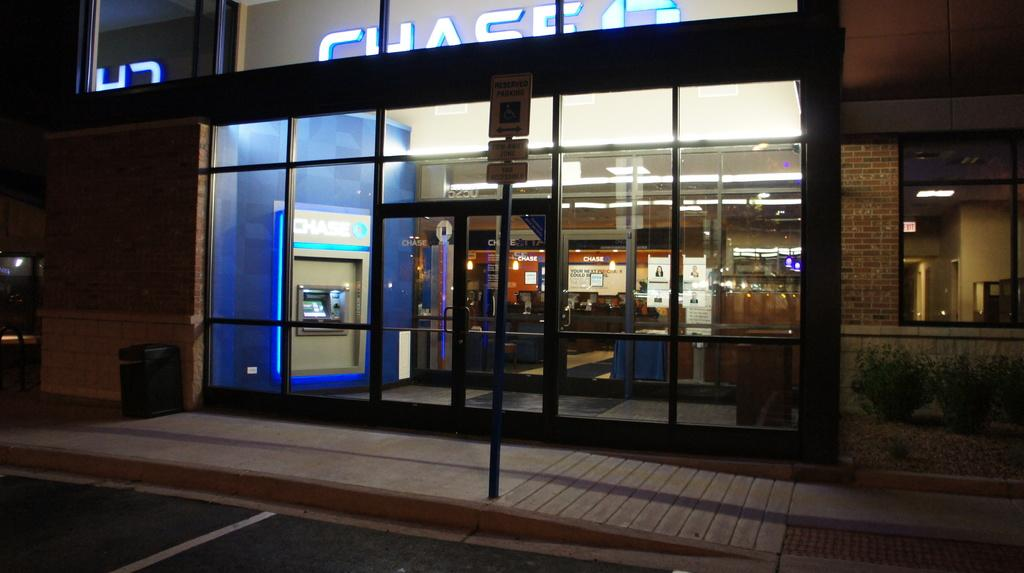<image>
Summarize the visual content of the image. Bank which has the name Chase in white letters on top. 